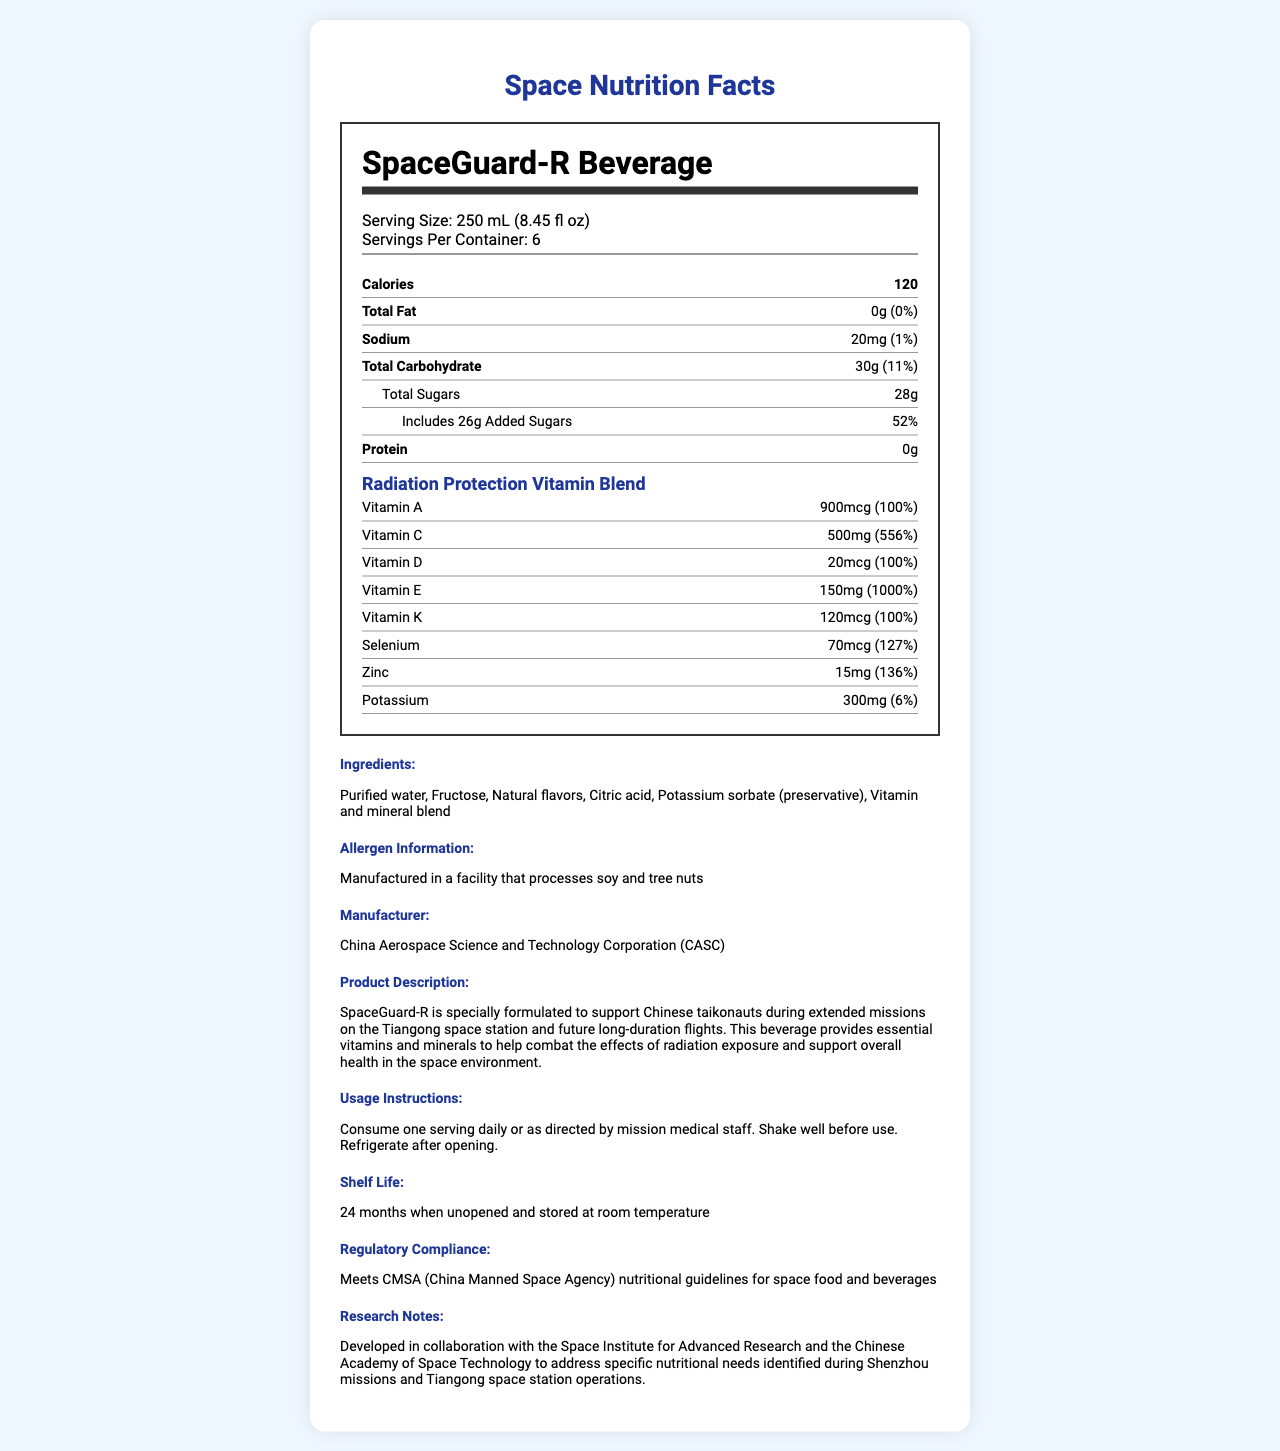what is the serving size for SpaceGuard-R Beverage? The serving size is clearly listed as 250 mL (8.45 fl oz) under 'Serving Size'.
Answer: 250 mL (8.45 fl oz) how many calories are in one serving of SpaceGuard-R Beverage? The calories are listed as 120 under the 'Calories' section.
Answer: 120 what is the daily value percentage of added sugars in SpaceGuard-R Beverage? The daily value percentage for added sugars is shown as 52% in the 'Total Sugars' section.
Answer: 52% which organization manufactures SpaceGuard-R Beverage? The manufacturer is mentioned under the 'manufacturer' section.
Answer: China Aerospace Science and Technology Corporation (CASC) what is the shelf life of SpaceGuard-R Beverage once unopened? The shelf life is indicated as 24 months when unopened and stored at room temperature.
Answer: 24 months when unopened and stored at room temperature what percentage of daily value for vitamin C does SpaceGuard-R Beverage provide? A. 100% B. 127% C. 556% D. 1000% Vitamin C provides 556% of the daily value, as listed under the 'vitamin_c' section.
Answer: C. 556% which of the following vitamins is present in the highest daily value percentage? I. Vitamin A II. Vitamin C III. Vitamin E IV. Vitamin K Vitamin E has a daily value percentage of 1000%, which is the highest among the listed vitamins.
Answer: III. Vitamin E is there any protein in SpaceGuard-R Beverage? The 'protein' section indicates 0g and 0% daily value, so there is no protein.
Answer: No provide a brief summary of SpaceGuard-R Beverage's nutrition facts and purpose The beverage is formulated to support taikonauts' health during extended space missions, offering essential nutrients to mitigate radiation effects.
Answer: SpaceGuard-R Beverage is a vitamin-enriched beverage designed to combat radiation exposure during long-duration Chinese space flights. It contains 120 calories per serving, with essential vitamins like A, C, D, E, and K, and minerals like selenium and zinc. It includes no fat, protein, or significant sodium but has high sugar content. The product is manufactured by CASC and meets CMSA guidelines. what is the source of flavor in SpaceGuard-R Beverage? The label mentions 'Natural flavors' as an ingredient but does not specify the exact source of the flavors. Therefore, the precise nature of the flavor source cannot be determined from the document.
Answer: Cannot be determined 